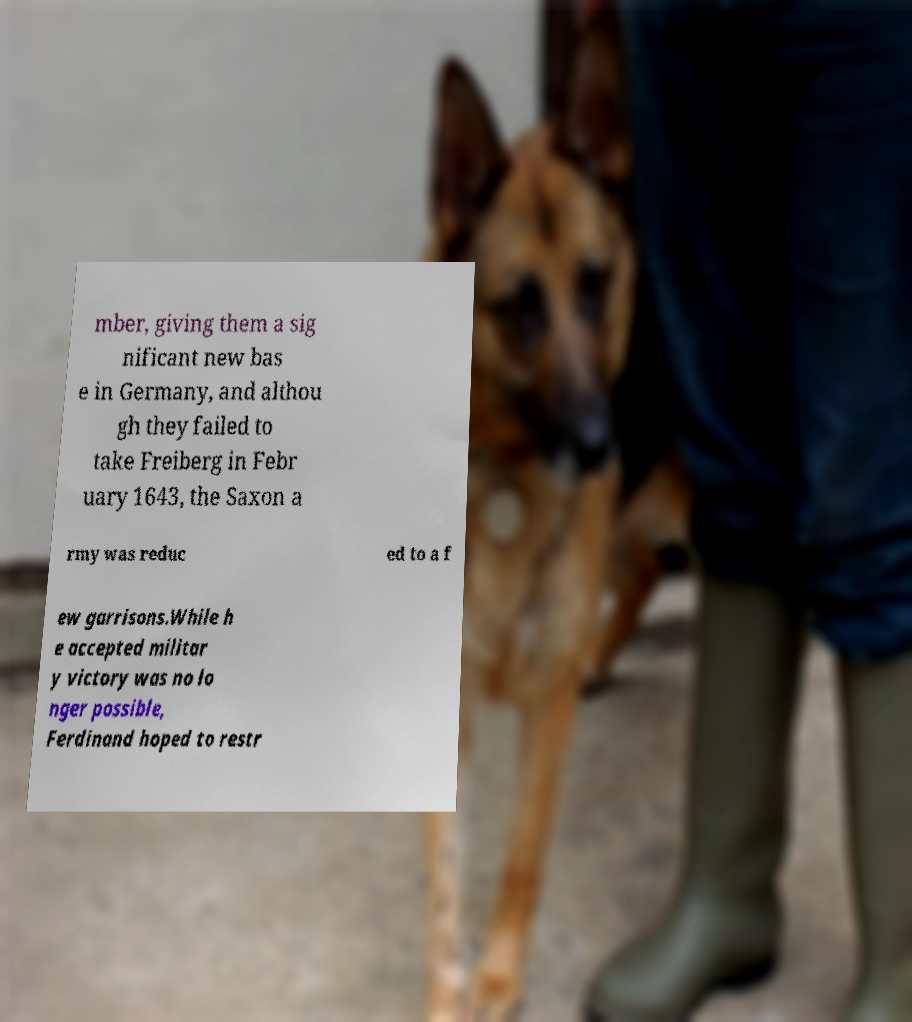Could you extract and type out the text from this image? mber, giving them a sig nificant new bas e in Germany, and althou gh they failed to take Freiberg in Febr uary 1643, the Saxon a rmy was reduc ed to a f ew garrisons.While h e accepted militar y victory was no lo nger possible, Ferdinand hoped to restr 